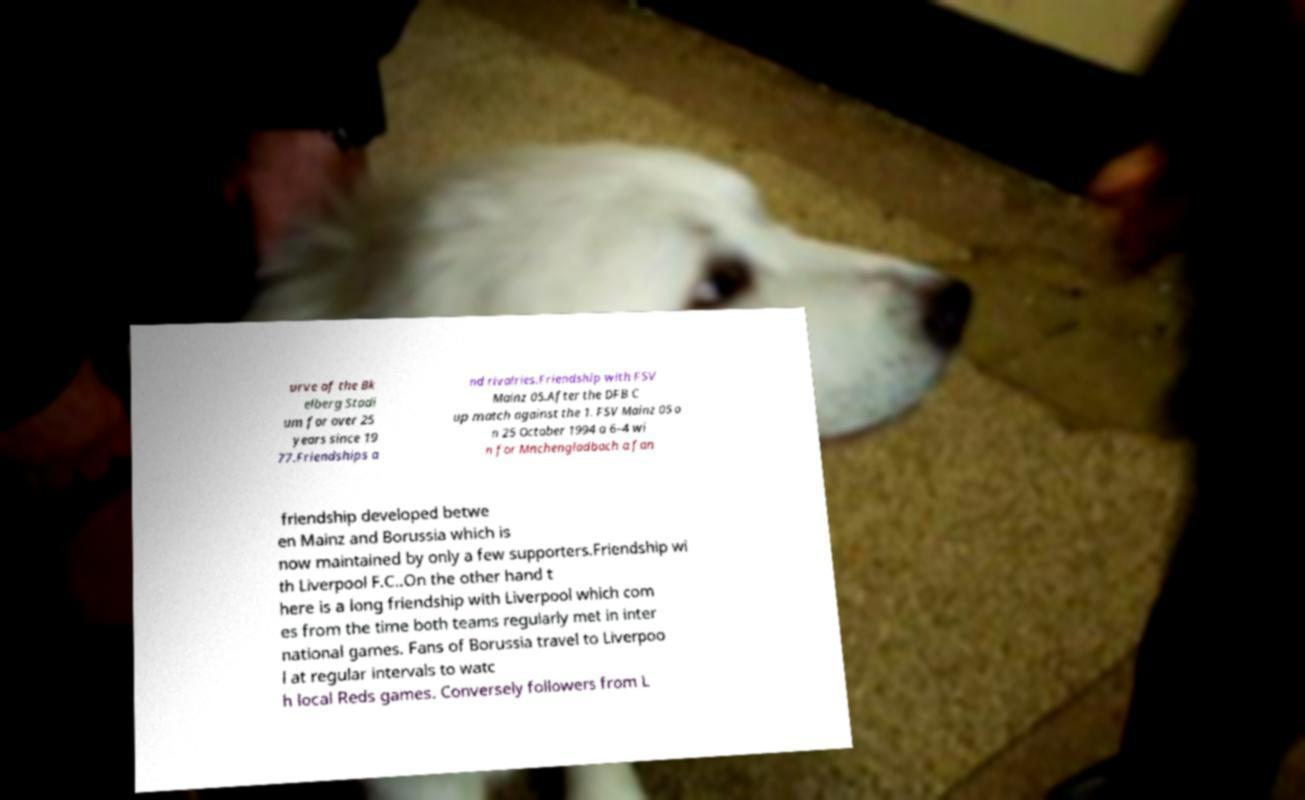For documentation purposes, I need the text within this image transcribed. Could you provide that? urve of the Bk elberg Stadi um for over 25 years since 19 77.Friendships a nd rivalries.Friendship with FSV Mainz 05.After the DFB C up match against the 1. FSV Mainz 05 o n 25 October 1994 a 6–4 wi n for Mnchengladbach a fan friendship developed betwe en Mainz and Borussia which is now maintained by only a few supporters.Friendship wi th Liverpool F.C..On the other hand t here is a long friendship with Liverpool which com es from the time both teams regularly met in inter national games. Fans of Borussia travel to Liverpoo l at regular intervals to watc h local Reds games. Conversely followers from L 